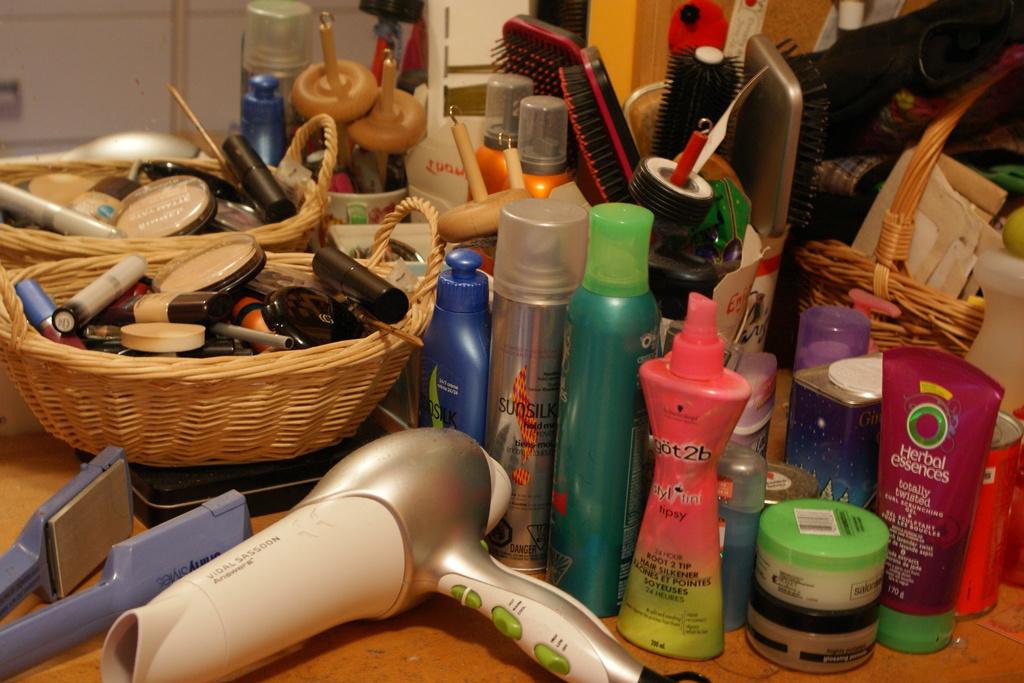What is the brand of the pink and yellow product?
Offer a very short reply. Got2b. 